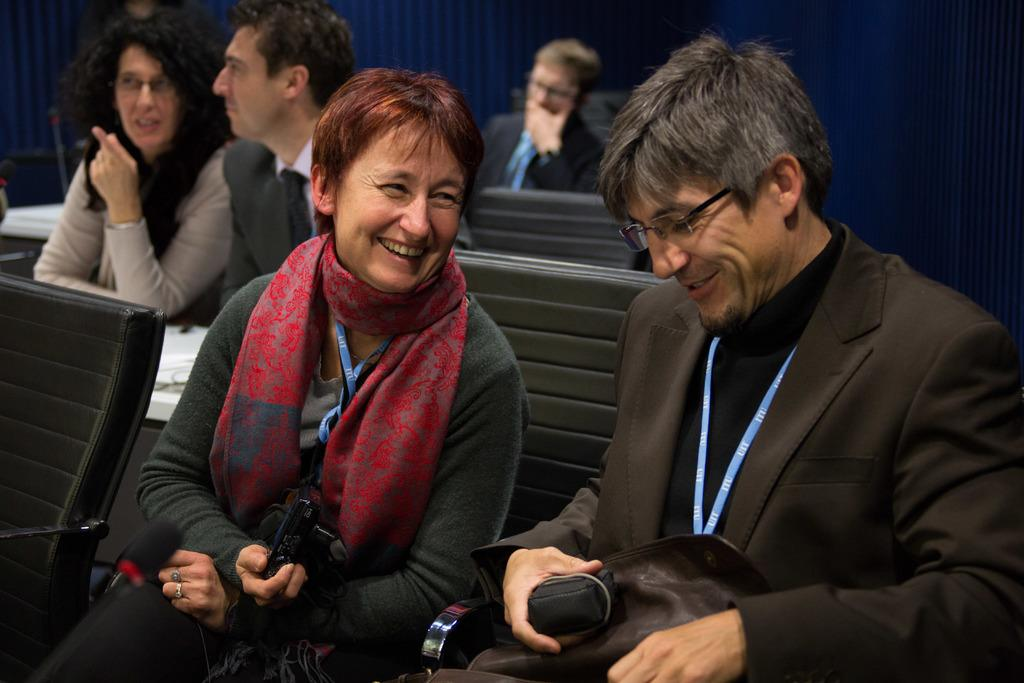What are the two persons in the image doing? The two persons in the image are sitting on chairs and smiling. Who is holding a camera in the image? There is a person holding a camera in the image. How many additional persons can be seen in the background? In the background, there are three persons sitting on chairs. What type of egg is being used as a prop in the image? There is no egg present in the image. Where is the vacation destination mentioned in the image? The image does not mention or depict a vacation destination. 